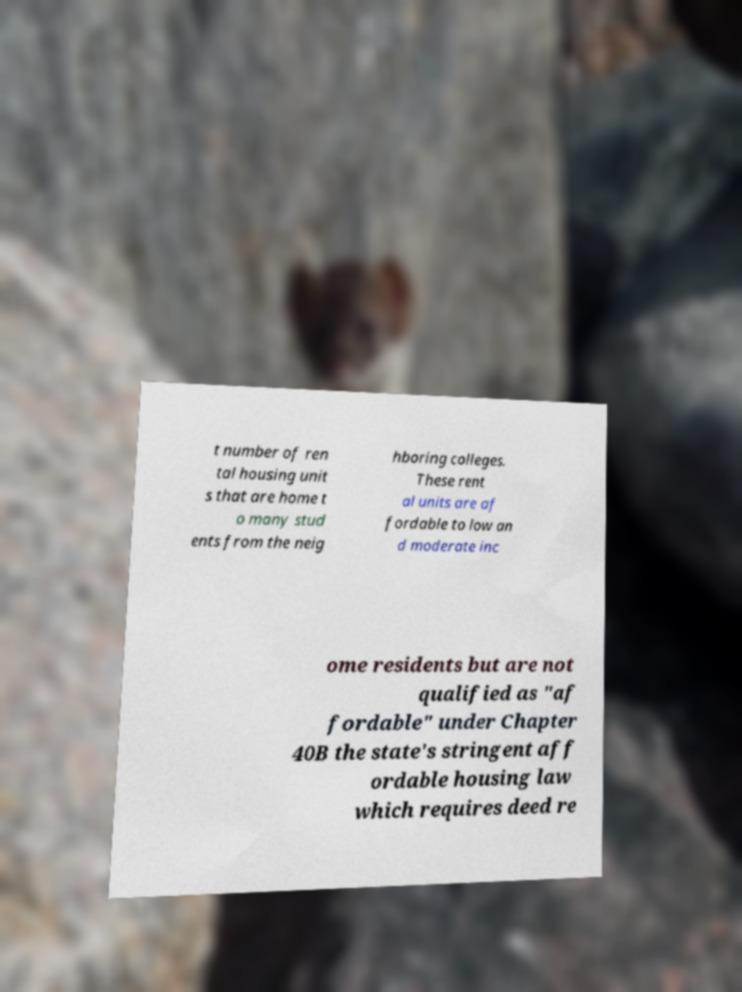Please identify and transcribe the text found in this image. t number of ren tal housing unit s that are home t o many stud ents from the neig hboring colleges. These rent al units are af fordable to low an d moderate inc ome residents but are not qualified as "af fordable" under Chapter 40B the state's stringent aff ordable housing law which requires deed re 